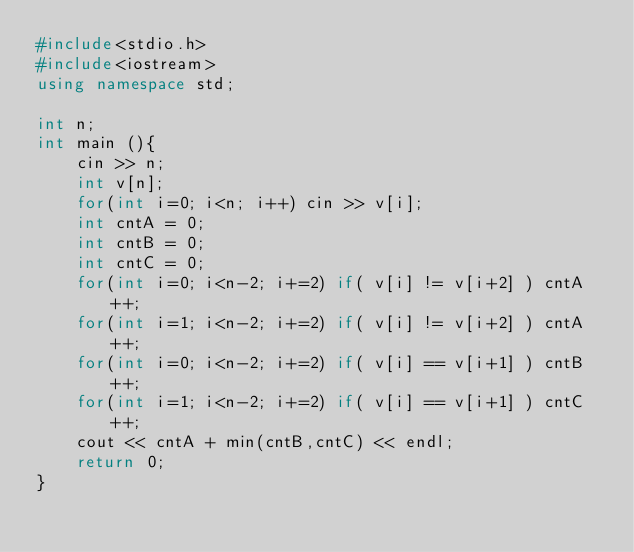<code> <loc_0><loc_0><loc_500><loc_500><_C++_>#include<stdio.h>
#include<iostream>
using namespace std;

int n;
int main (){
    cin >> n;
    int v[n];
    for(int i=0; i<n; i++) cin >> v[i];
    int cntA = 0;
    int cntB = 0;
    int cntC = 0;
    for(int i=0; i<n-2; i+=2) if( v[i] != v[i+2] ) cntA++;
    for(int i=1; i<n-2; i+=2) if( v[i] != v[i+2] ) cntA++;
    for(int i=0; i<n-2; i+=2) if( v[i] == v[i+1] ) cntB++;
    for(int i=1; i<n-2; i+=2) if( v[i] == v[i+1] ) cntC++;
    cout << cntA + min(cntB,cntC) << endl;
    return 0;
}
</code> 